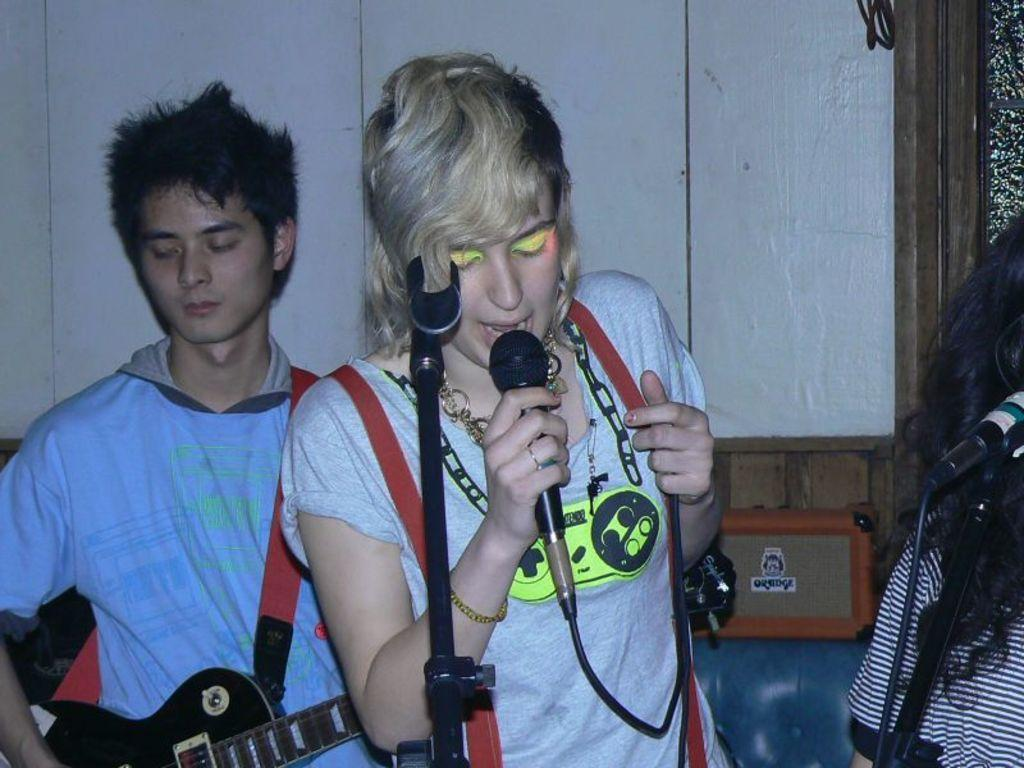Who are the people in the image? There is a woman and a man in the image. What are the woman and man doing in the image? The woman is singing on a microphone, and the man is playing a guitar. What type of fish can be seen swimming in the background of the image? There are no fish present in the image; it features a woman singing on a microphone and a man playing a guitar. What is the woman using to shape the wax in the image? There is no wax or any wax-shaping activity depicted in the image. 